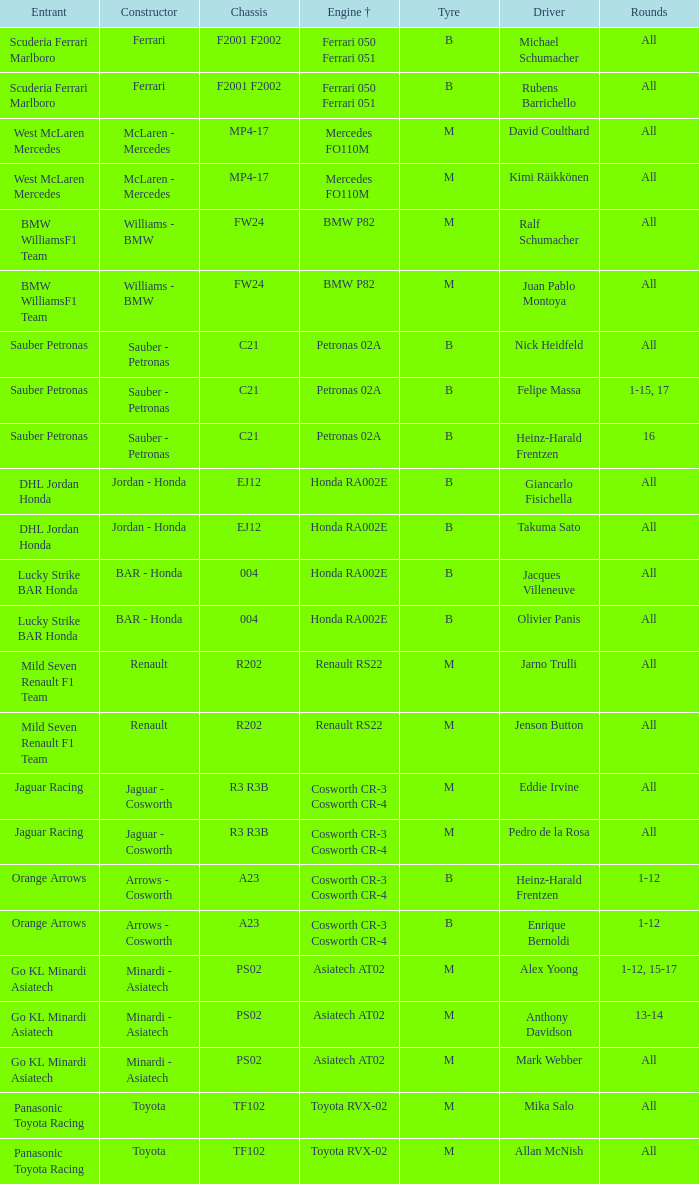Who is the competitor when the powertrain is bmw p82? BMW WilliamsF1 Team, BMW WilliamsF1 Team. 